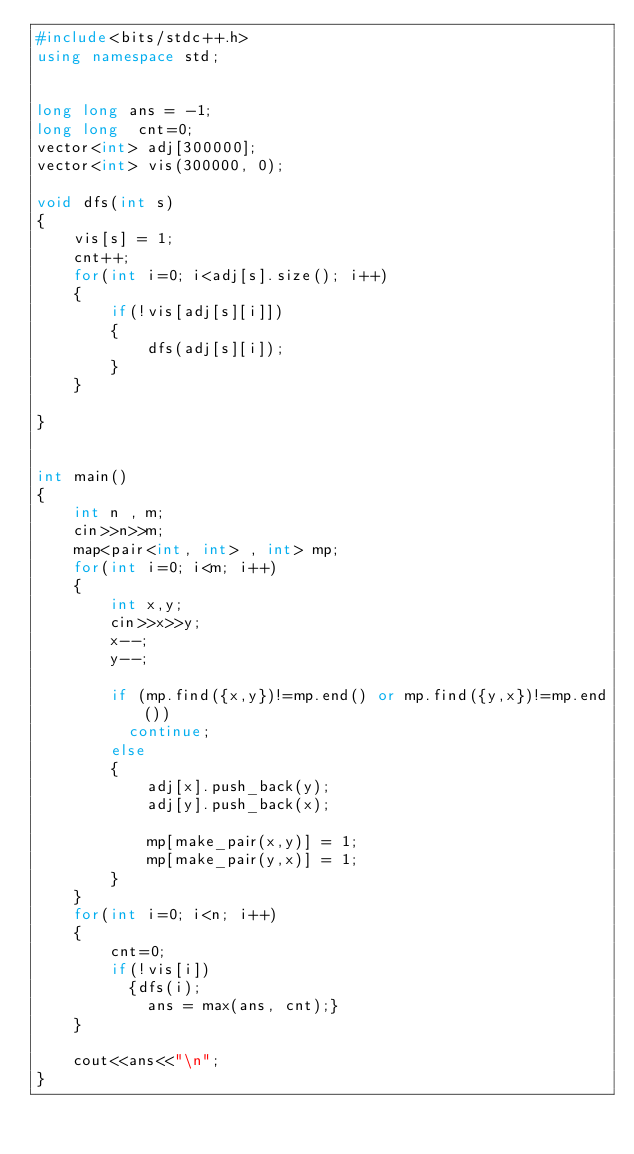<code> <loc_0><loc_0><loc_500><loc_500><_C++_>#include<bits/stdc++.h>
using namespace std;


long long ans = -1;
long long  cnt=0;
vector<int> adj[300000];
vector<int> vis(300000, 0);

void dfs(int s)
{
    vis[s] = 1;
    cnt++;
    for(int i=0; i<adj[s].size(); i++)
    {
        if(!vis[adj[s][i]])
        {
            dfs(adj[s][i]);
        }
    }
    
}


int main()
{
    int n , m;
    cin>>n>>m;
    map<pair<int, int> , int> mp;
    for(int i=0; i<m; i++)
    {
        int x,y;
        cin>>x>>y;
        x--;
        y--;
        
        if (mp.find({x,y})!=mp.end() or mp.find({y,x})!=mp.end())
          continue;
        else
        {
            adj[x].push_back(y);
            adj[y].push_back(x);
            
            mp[make_pair(x,y)] = 1;
            mp[make_pair(y,x)] = 1;
        }
    }
    for(int i=0; i<n; i++)
    {
        cnt=0;
        if(!vis[i])
          {dfs(i);
            ans = max(ans, cnt);}
    }
    
    cout<<ans<<"\n";
}</code> 